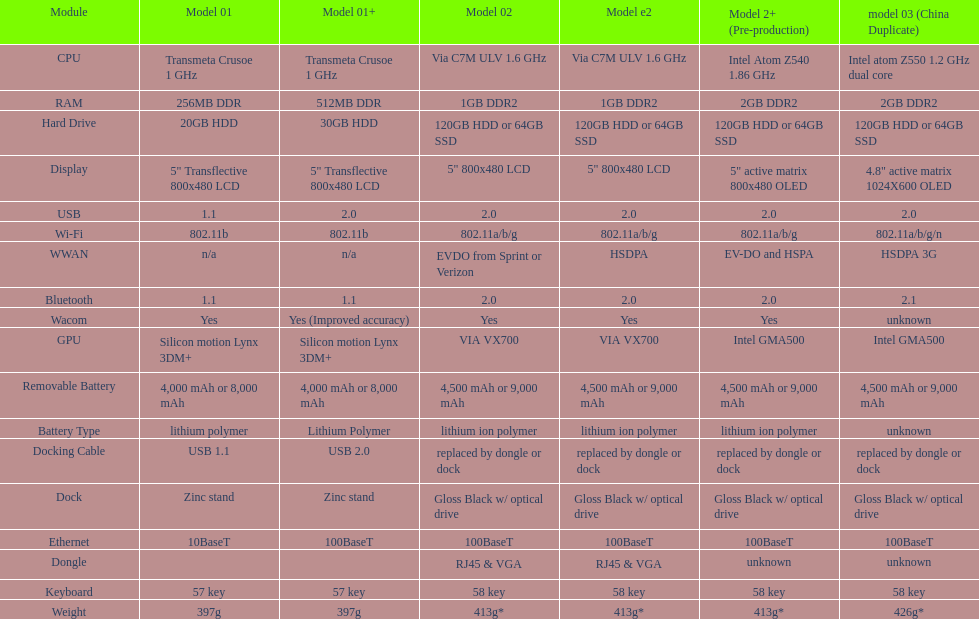What component comes after bluetooth? Wacom. 